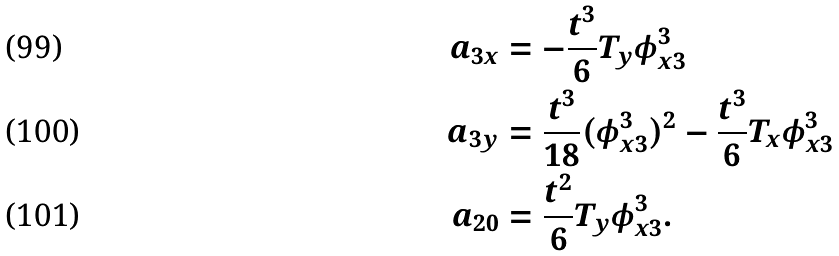<formula> <loc_0><loc_0><loc_500><loc_500>a _ { 3 x } & = - \frac { t ^ { 3 } } { 6 } T _ { y } \phi ^ { 3 } _ { x 3 } \\ a _ { 3 y } & = \frac { t ^ { 3 } } { 1 8 } ( \phi ^ { 3 } _ { x 3 } ) ^ { 2 } - \frac { t ^ { 3 } } { 6 } T _ { x } \phi ^ { 3 } _ { x 3 } \\ a _ { 2 0 } & = \frac { t ^ { 2 } } { 6 } T _ { y } \phi ^ { 3 } _ { x 3 } .</formula> 